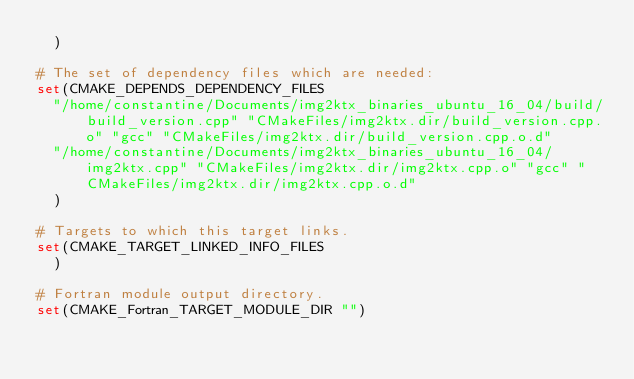<code> <loc_0><loc_0><loc_500><loc_500><_CMake_>  )

# The set of dependency files which are needed:
set(CMAKE_DEPENDS_DEPENDENCY_FILES
  "/home/constantine/Documents/img2ktx_binaries_ubuntu_16_04/build/build_version.cpp" "CMakeFiles/img2ktx.dir/build_version.cpp.o" "gcc" "CMakeFiles/img2ktx.dir/build_version.cpp.o.d"
  "/home/constantine/Documents/img2ktx_binaries_ubuntu_16_04/img2ktx.cpp" "CMakeFiles/img2ktx.dir/img2ktx.cpp.o" "gcc" "CMakeFiles/img2ktx.dir/img2ktx.cpp.o.d"
  )

# Targets to which this target links.
set(CMAKE_TARGET_LINKED_INFO_FILES
  )

# Fortran module output directory.
set(CMAKE_Fortran_TARGET_MODULE_DIR "")
</code> 